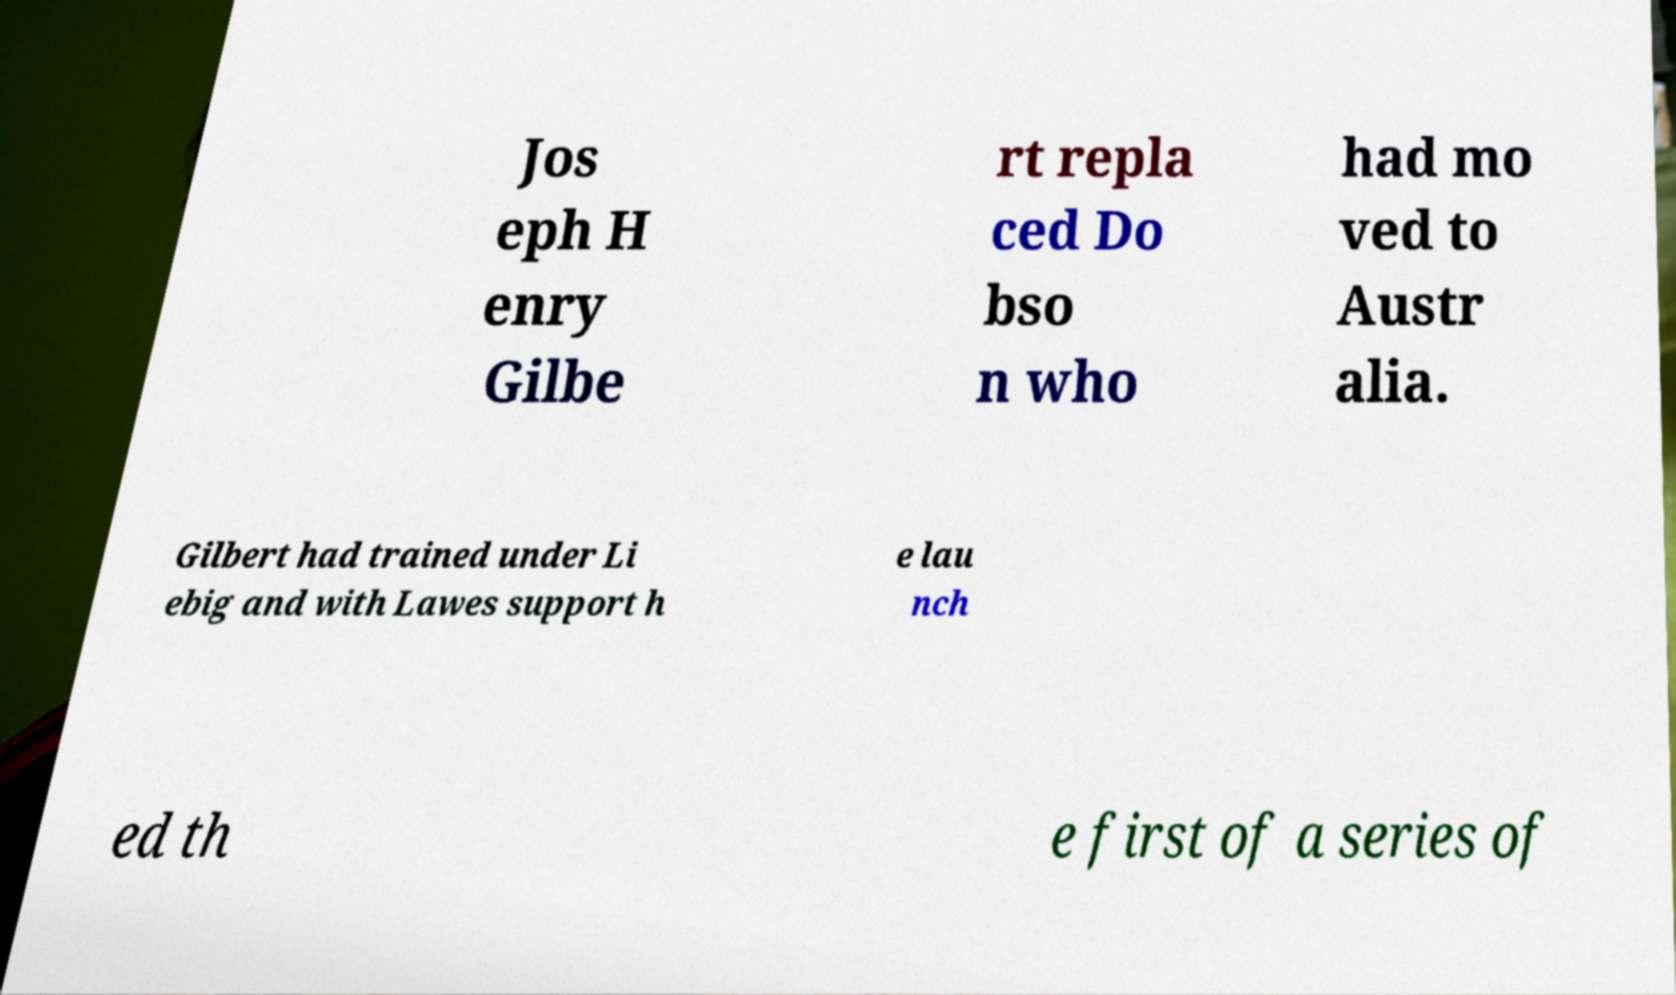I need the written content from this picture converted into text. Can you do that? Jos eph H enry Gilbe rt repla ced Do bso n who had mo ved to Austr alia. Gilbert had trained under Li ebig and with Lawes support h e lau nch ed th e first of a series of 